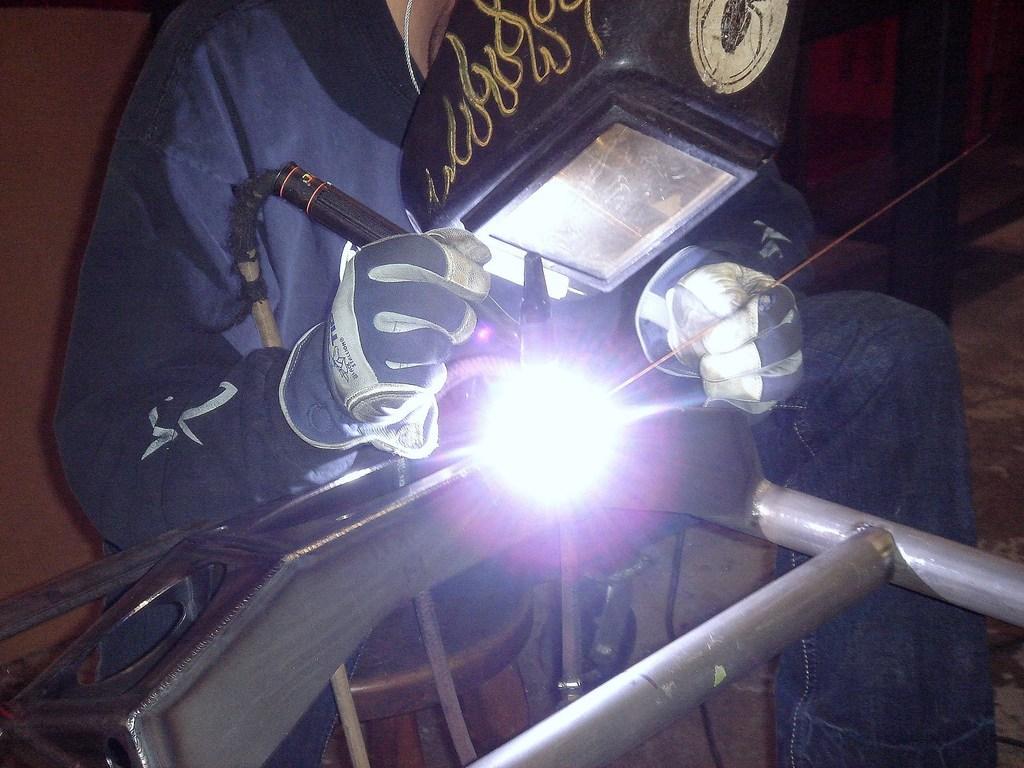Can you describe this image briefly? The picture consists of a person welding an iron frame. The person is wearing a helmet. At the bottom there is a stool. In the background it is well. 